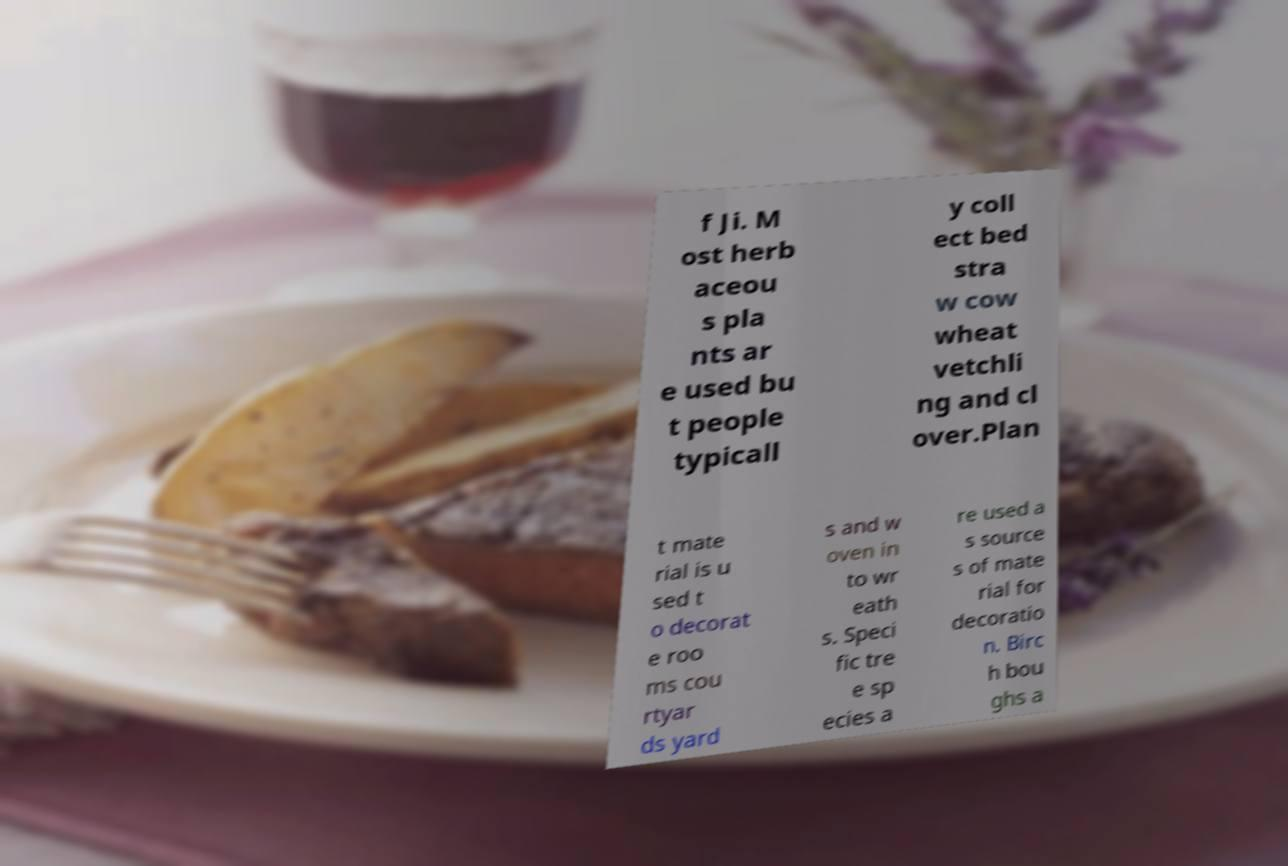Could you extract and type out the text from this image? f Ji. M ost herb aceou s pla nts ar e used bu t people typicall y coll ect bed stra w cow wheat vetchli ng and cl over.Plan t mate rial is u sed t o decorat e roo ms cou rtyar ds yard s and w oven in to wr eath s. Speci fic tre e sp ecies a re used a s source s of mate rial for decoratio n. Birc h bou ghs a 